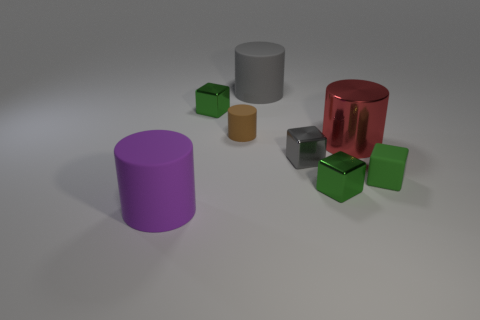Subtract all matte cylinders. How many cylinders are left? 1 Subtract all big gray matte objects. Subtract all big gray cylinders. How many objects are left? 6 Add 4 big gray objects. How many big gray objects are left? 5 Add 4 red objects. How many red objects exist? 5 Add 1 tiny cyan metallic spheres. How many objects exist? 9 Subtract all gray cubes. How many cubes are left? 3 Subtract 1 gray blocks. How many objects are left? 7 Subtract 3 cubes. How many cubes are left? 1 Subtract all green cylinders. Subtract all yellow spheres. How many cylinders are left? 4 Subtract all brown cylinders. How many cyan cubes are left? 0 